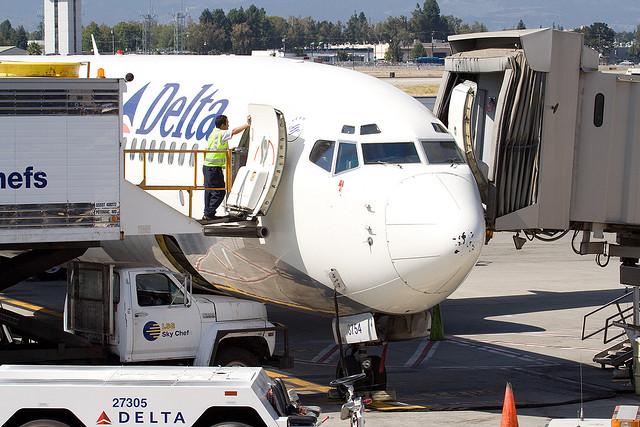Where is the plane?
Keep it brief. Airport. Could passenger be boarding?
Answer briefly. No. Is the weather good for flying?
Quick response, please. Yes. What airline operates the plane?
Be succinct. Delta. 